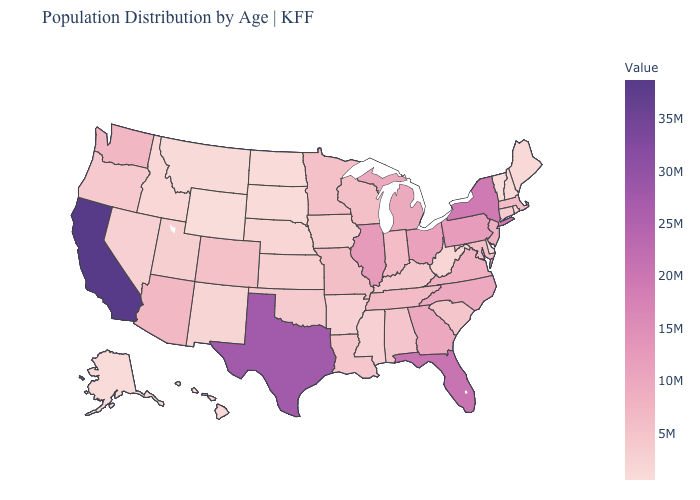Does Florida have the highest value in the USA?
Answer briefly. No. Which states have the highest value in the USA?
Quick response, please. California. Among the states that border Indiana , which have the lowest value?
Write a very short answer. Kentucky. Which states have the lowest value in the USA?
Write a very short answer. Wyoming. Among the states that border Maryland , does Delaware have the lowest value?
Answer briefly. Yes. Does Ohio have a lower value than Texas?
Keep it brief. Yes. 